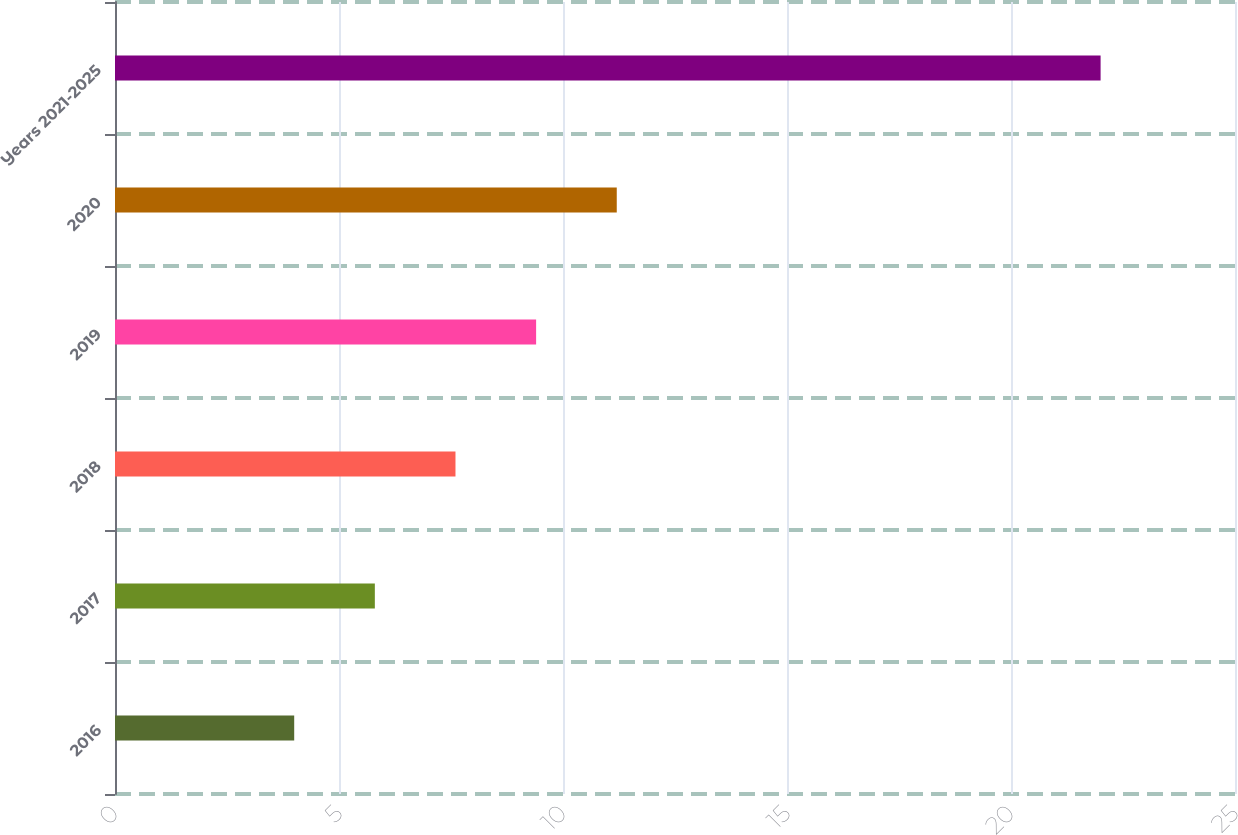Convert chart. <chart><loc_0><loc_0><loc_500><loc_500><bar_chart><fcel>2016<fcel>2017<fcel>2018<fcel>2019<fcel>2020<fcel>Years 2021-2025<nl><fcel>4<fcel>5.8<fcel>7.6<fcel>9.4<fcel>11.2<fcel>22<nl></chart> 